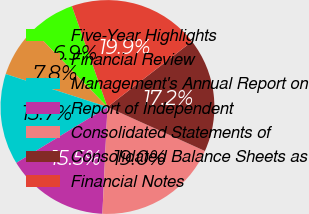<chart> <loc_0><loc_0><loc_500><loc_500><pie_chart><fcel>Five-Year Highlights<fcel>Financial Review<fcel>Management's Annual Report on<fcel>Report of Independent<fcel>Consolidated Statements of<fcel>Consolidated Balance Sheets as<fcel>Financial Notes<nl><fcel>6.87%<fcel>7.75%<fcel>13.74%<fcel>15.49%<fcel>19.01%<fcel>17.25%<fcel>19.89%<nl></chart> 